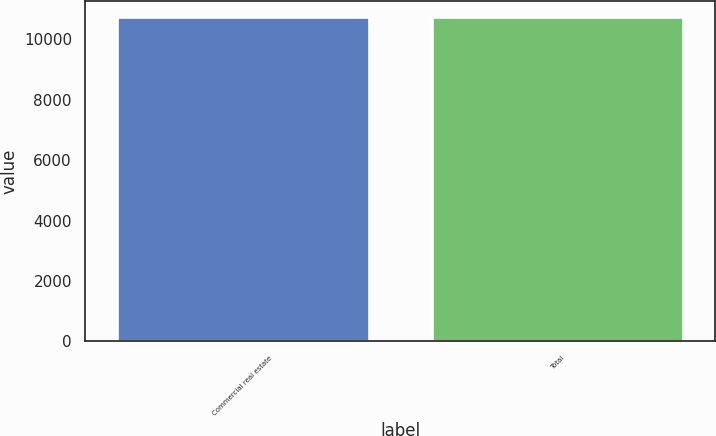<chart> <loc_0><loc_0><loc_500><loc_500><bar_chart><fcel>Commercial real estate<fcel>Total<nl><fcel>10750<fcel>10750.1<nl></chart> 